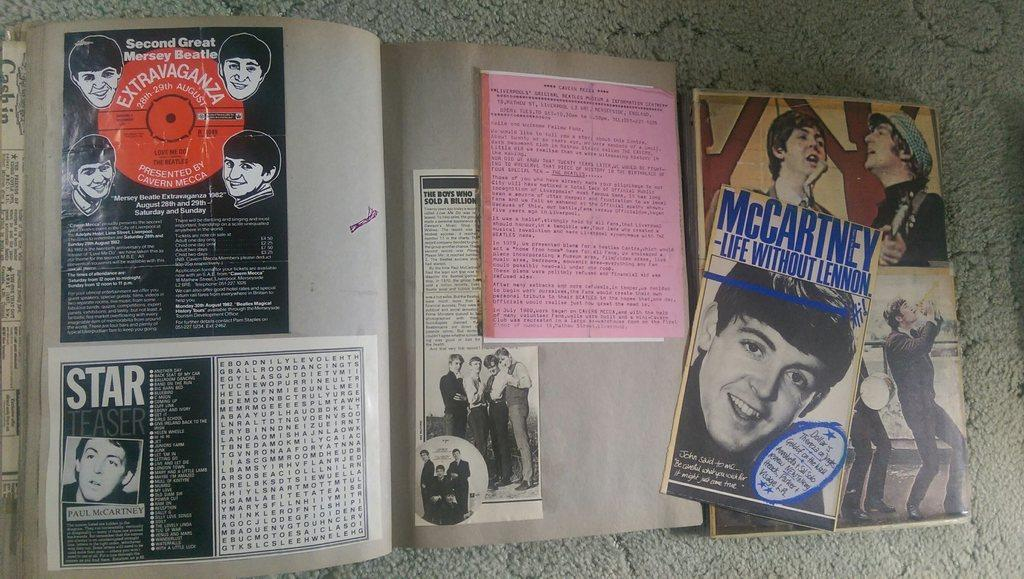<image>
Give a short and clear explanation of the subsequent image. Several flyers on the wall advertise The Beatles and Paul McCartney. 